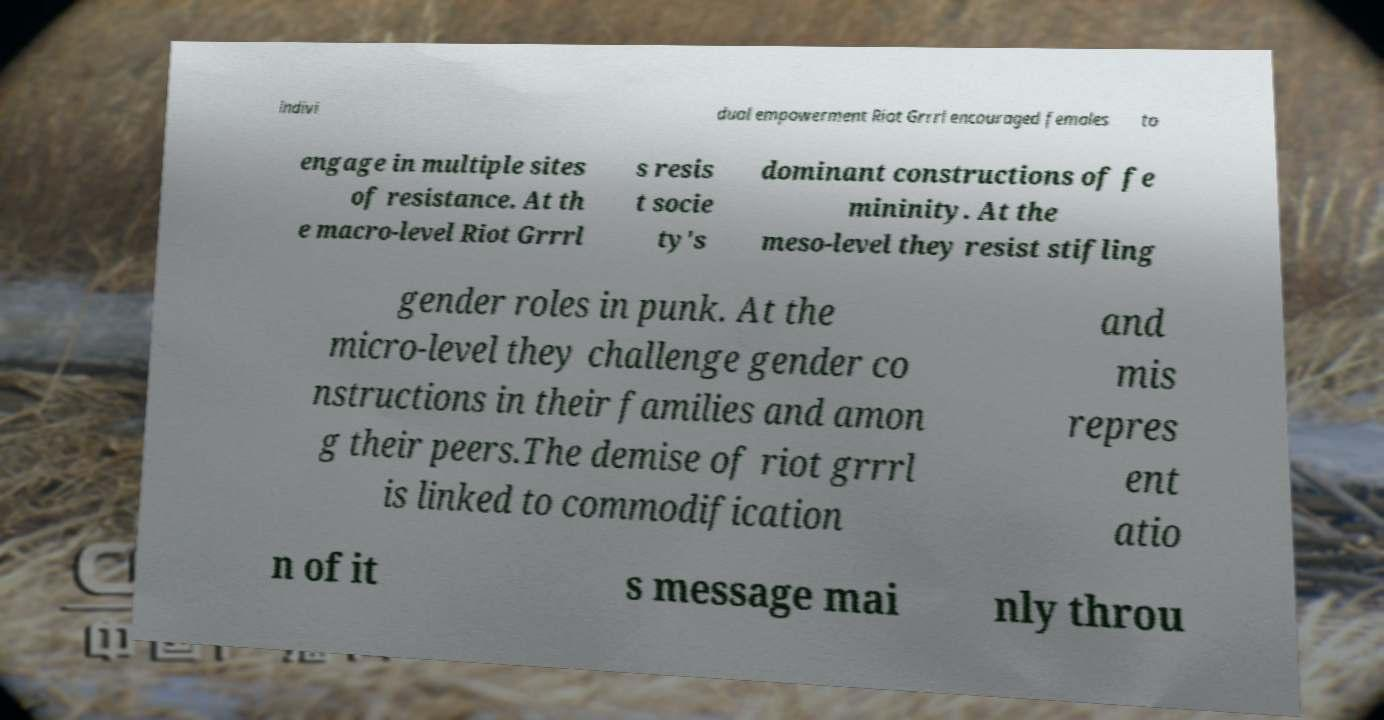There's text embedded in this image that I need extracted. Can you transcribe it verbatim? indivi dual empowerment Riot Grrrl encouraged females to engage in multiple sites of resistance. At th e macro-level Riot Grrrl s resis t socie ty's dominant constructions of fe mininity. At the meso-level they resist stifling gender roles in punk. At the micro-level they challenge gender co nstructions in their families and amon g their peers.The demise of riot grrrl is linked to commodification and mis repres ent atio n of it s message mai nly throu 